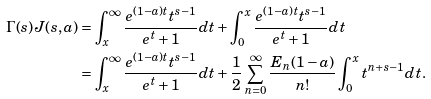<formula> <loc_0><loc_0><loc_500><loc_500>\Gamma ( s ) J ( s , a ) & = \int _ { x } ^ { \infty } \frac { e ^ { ( 1 - a ) t } t ^ { s - 1 } } { e ^ { t } + 1 } d t + \int _ { 0 } ^ { x } \frac { e ^ { ( 1 - a ) t } t ^ { s - 1 } } { e ^ { t } + 1 } d t \\ & = \int _ { x } ^ { \infty } \frac { e ^ { ( 1 - a ) t } t ^ { s - 1 } } { e ^ { t } + 1 } d t + \frac { 1 } { 2 } \sum _ { n = 0 } ^ { \infty } \frac { E _ { n } ( 1 - a ) } { n ! } \int _ { 0 } ^ { x } t ^ { n + s - 1 } d t .</formula> 